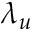<formula> <loc_0><loc_0><loc_500><loc_500>\lambda _ { u }</formula> 